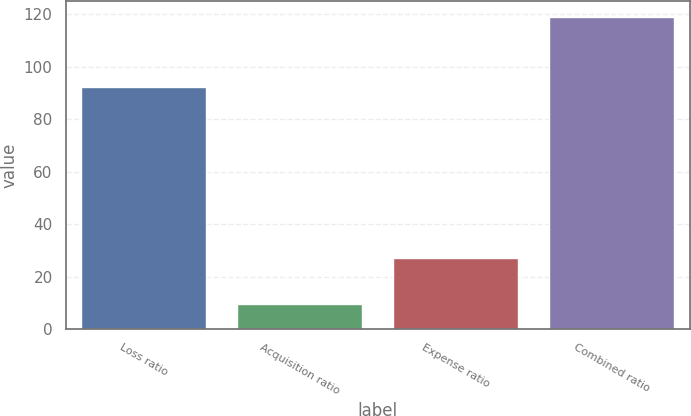<chart> <loc_0><loc_0><loc_500><loc_500><bar_chart><fcel>Loss ratio<fcel>Acquisition ratio<fcel>Expense ratio<fcel>Combined ratio<nl><fcel>92.2<fcel>9.5<fcel>27<fcel>119.2<nl></chart> 